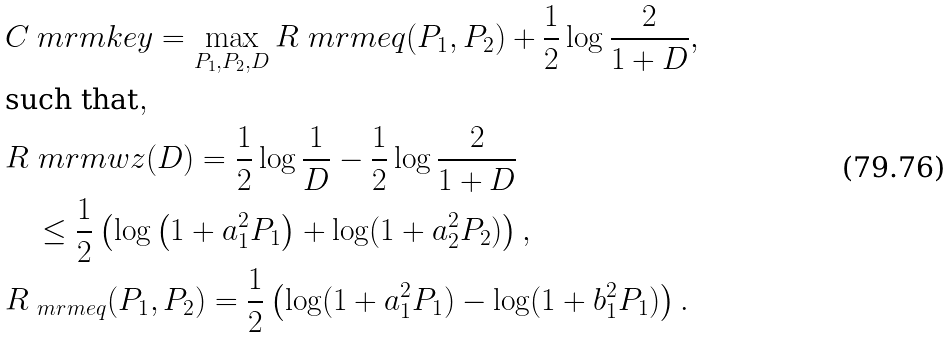Convert formula to latex. <formula><loc_0><loc_0><loc_500><loc_500>& C _ { \ } m r m { k e y } = \max _ { P _ { 1 } , P _ { 2 } , D } R _ { \ } m r m { e q } ( P _ { 1 } , P _ { 2 } ) + \frac { 1 } { 2 } \log \frac { 2 } { 1 + D } , \\ & \text {such that} , \\ & R _ { \ } m r m { w z } ( D ) = \frac { 1 } { 2 } \log \frac { 1 } { D } - \frac { 1 } { 2 } \log \frac { 2 } { 1 + D } \\ & \quad \leq \frac { 1 } { 2 } \left ( \log \left ( 1 + a _ { 1 } ^ { 2 } P _ { 1 } \right ) + \log ( 1 + a _ { 2 } ^ { 2 } P _ { 2 } ) \right ) , \\ & R _ { \ m r m { e q } } ( P _ { 1 } , P _ { 2 } ) = \frac { 1 } { 2 } \left ( \log ( 1 + a _ { 1 } ^ { 2 } P _ { 1 } ) - \log ( 1 + b _ { 1 } ^ { 2 } P _ { 1 } ) \right ) .</formula> 